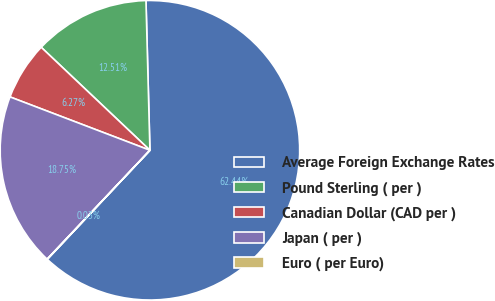Convert chart to OTSL. <chart><loc_0><loc_0><loc_500><loc_500><pie_chart><fcel>Average Foreign Exchange Rates<fcel>Pound Sterling ( per )<fcel>Canadian Dollar (CAD per )<fcel>Japan ( per )<fcel>Euro ( per Euro)<nl><fcel>62.43%<fcel>12.51%<fcel>6.27%<fcel>18.75%<fcel>0.03%<nl></chart> 